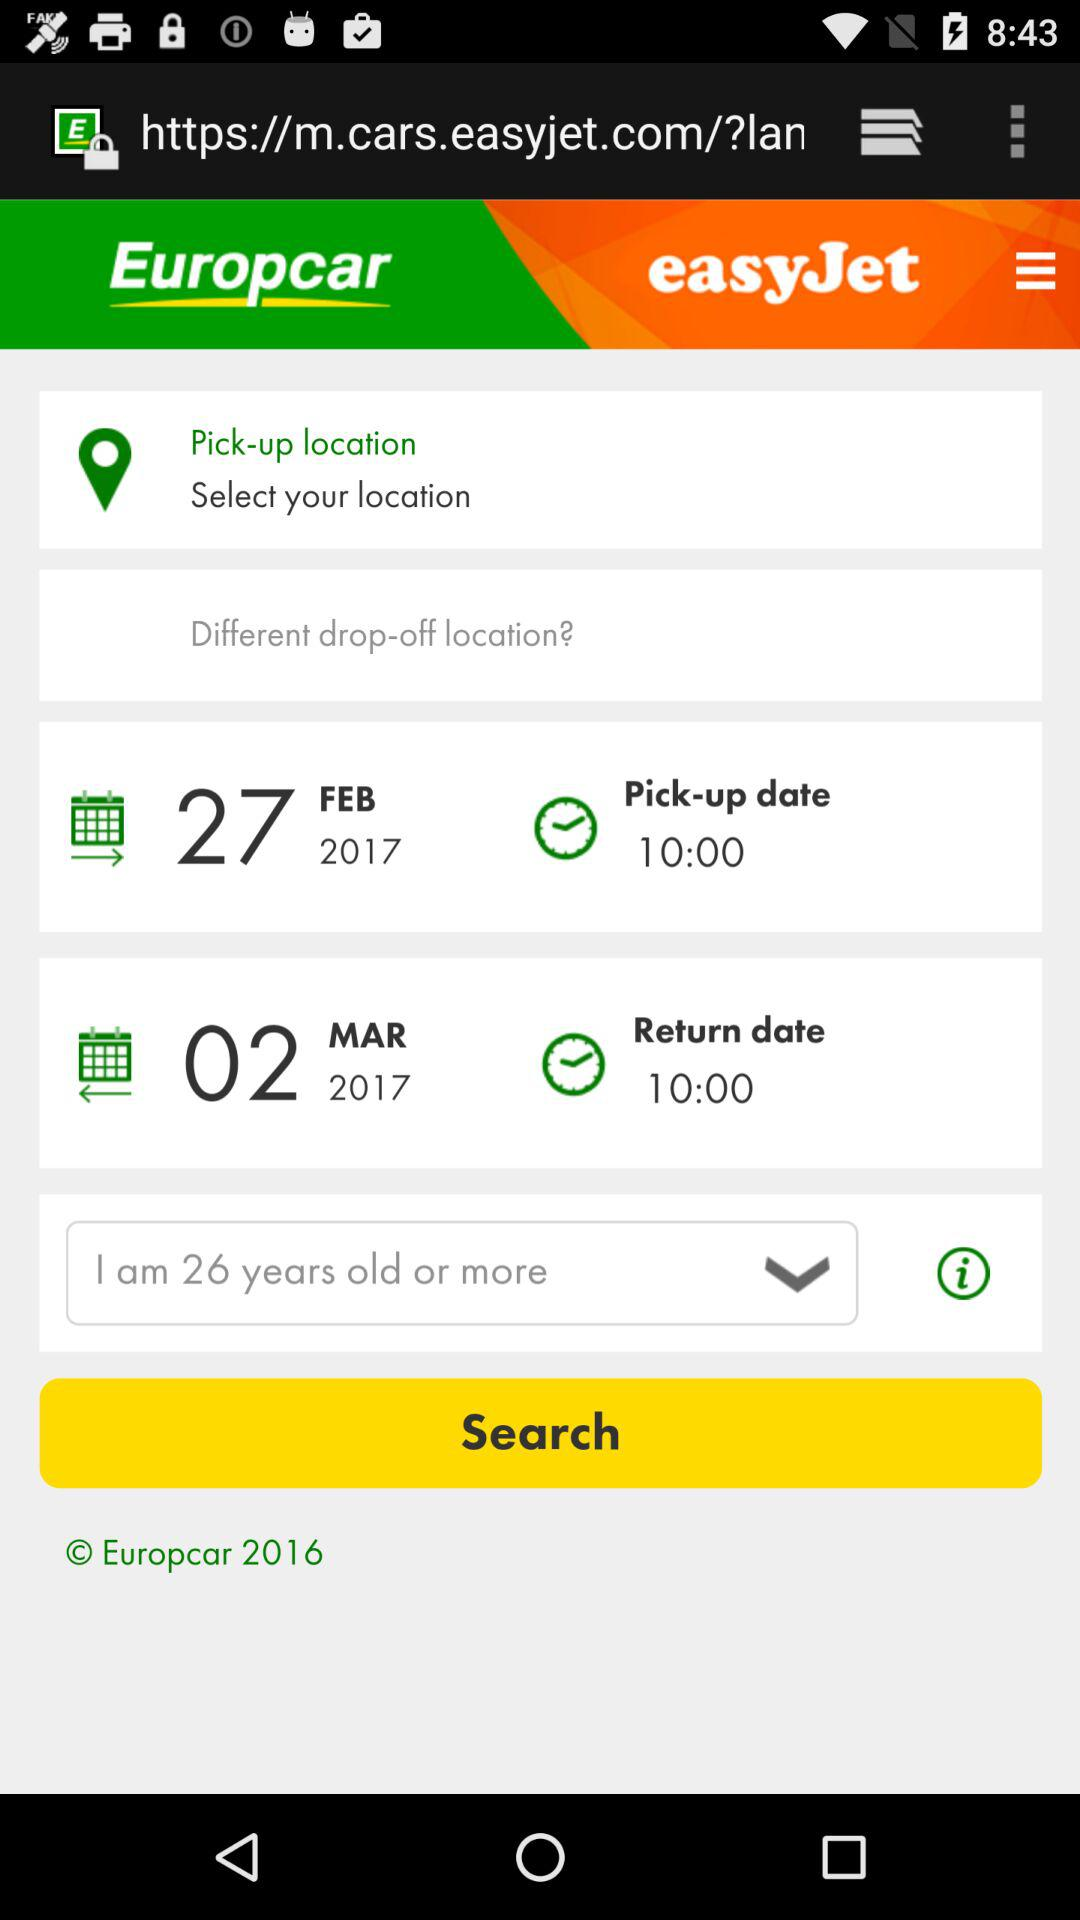What's the return date? The return date is March 2, 2017. 